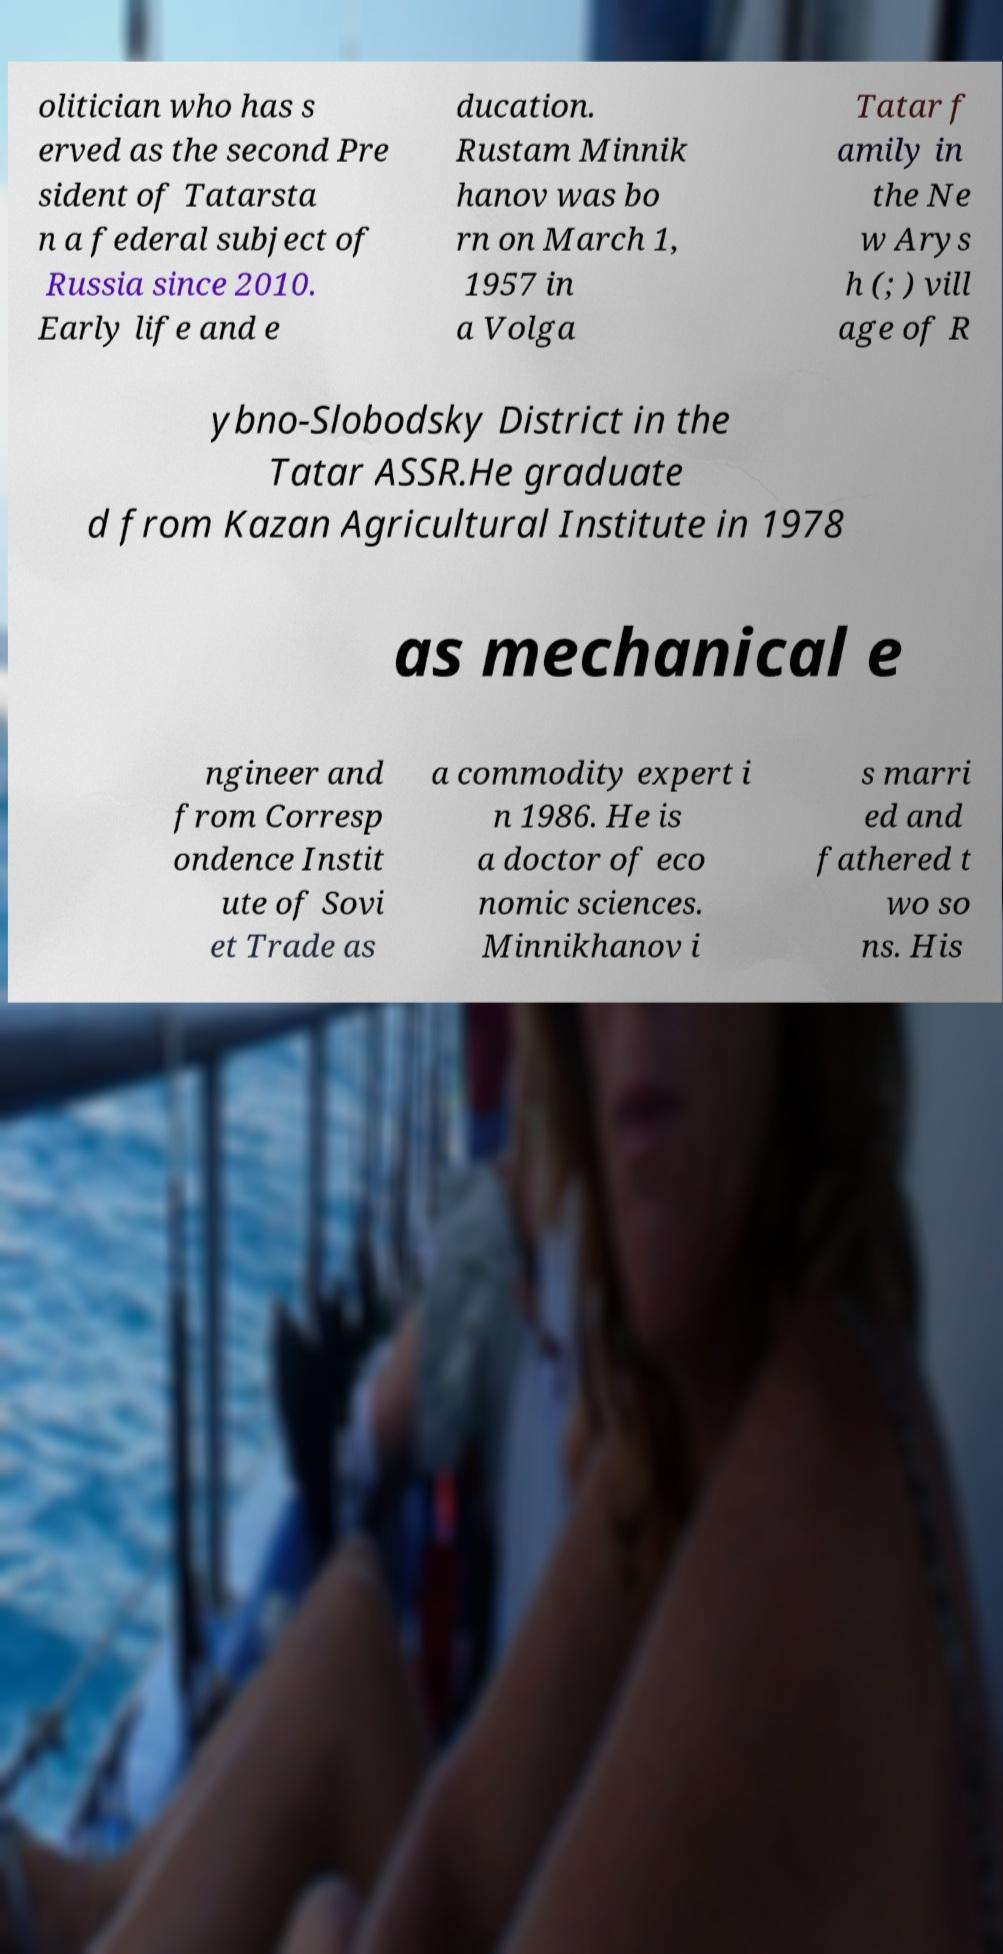Can you accurately transcribe the text from the provided image for me? olitician who has s erved as the second Pre sident of Tatarsta n a federal subject of Russia since 2010. Early life and e ducation. Rustam Minnik hanov was bo rn on March 1, 1957 in a Volga Tatar f amily in the Ne w Arys h (; ) vill age of R ybno-Slobodsky District in the Tatar ASSR.He graduate d from Kazan Agricultural Institute in 1978 as mechanical e ngineer and from Corresp ondence Instit ute of Sovi et Trade as a commodity expert i n 1986. He is a doctor of eco nomic sciences. Minnikhanov i s marri ed and fathered t wo so ns. His 